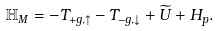<formula> <loc_0><loc_0><loc_500><loc_500>\mathbb { H } _ { M } = - T _ { + g , \uparrow } - T _ { - g , \downarrow } + \widetilde { U } + H _ { p } .</formula> 